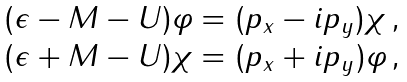<formula> <loc_0><loc_0><loc_500><loc_500>\begin{matrix} ( \epsilon - M - U ) \varphi = ( p _ { x } - i p _ { y } ) \chi \, , \\ ( \epsilon + M - U ) \chi = ( p _ { x } + i p _ { y } ) \varphi \, , \end{matrix}</formula> 